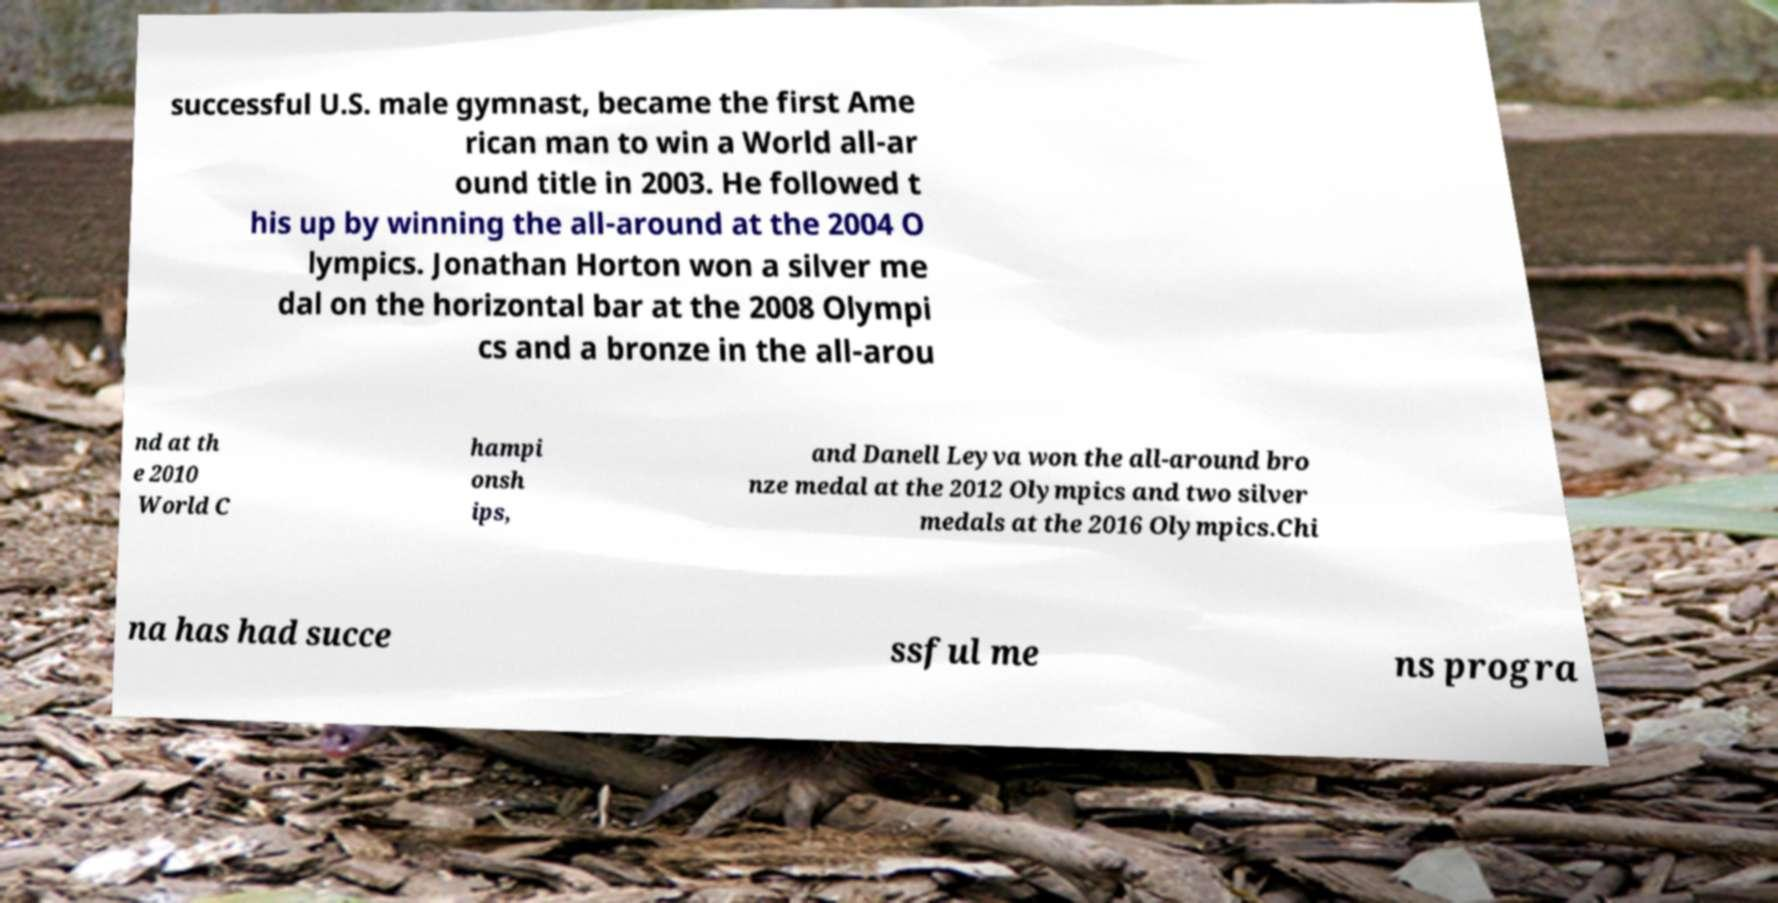I need the written content from this picture converted into text. Can you do that? successful U.S. male gymnast, became the first Ame rican man to win a World all-ar ound title in 2003. He followed t his up by winning the all-around at the 2004 O lympics. Jonathan Horton won a silver me dal on the horizontal bar at the 2008 Olympi cs and a bronze in the all-arou nd at th e 2010 World C hampi onsh ips, and Danell Leyva won the all-around bro nze medal at the 2012 Olympics and two silver medals at the 2016 Olympics.Chi na has had succe ssful me ns progra 